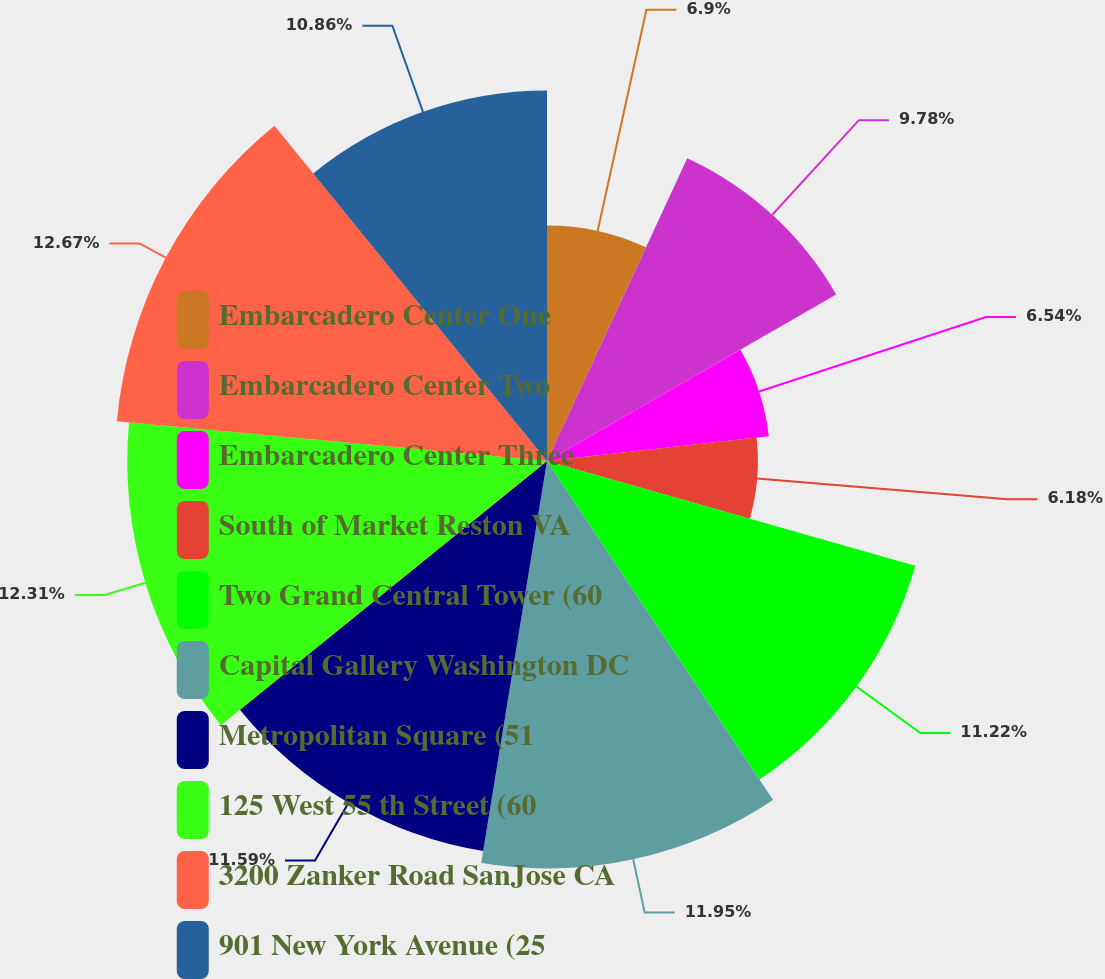<chart> <loc_0><loc_0><loc_500><loc_500><pie_chart><fcel>Embarcadero Center One<fcel>Embarcadero Center Two<fcel>Embarcadero Center Three<fcel>South of Market Reston VA<fcel>Two Grand Central Tower (60<fcel>Capital Gallery Washington DC<fcel>Metropolitan Square (51<fcel>125 West 55 th Street (60<fcel>3200 Zanker Road SanJose CA<fcel>901 New York Avenue (25<nl><fcel>6.9%<fcel>9.78%<fcel>6.54%<fcel>6.18%<fcel>11.22%<fcel>11.94%<fcel>11.58%<fcel>12.3%<fcel>12.66%<fcel>10.86%<nl></chart> 